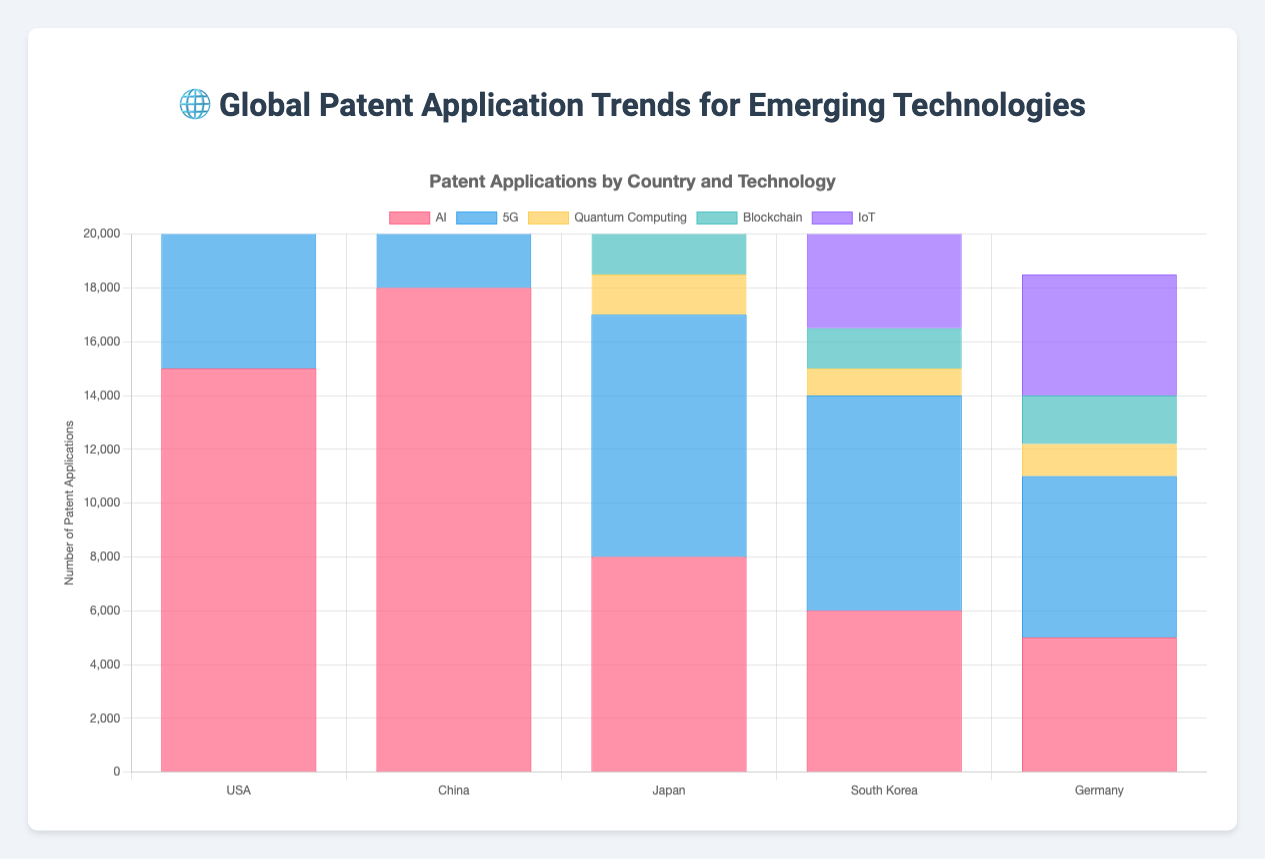Which country has the highest number of patent applications for AI? The bars representing AI patents show China leads with the highest bar.
Answer: China How many more AI patent applications does China have compared to Japan? China's AI patents = 18000; Japan's AI patents = 8000. Difference = 18000 - 8000 = 10000
Answer: 10000 Which technology has the fewest patent applications in Germany? The bar representing Quantum Computing for Germany is the shortest.
Answer: Quantum Computing Comparing AI and 5G patents, which country has the closest number in these categories? USA has 15000 AI and 12000 5G patents, with a difference of 3000, which is relatively small compared to other countries.
Answer: USA What is the total number of patent applications for IoT across all countries? Summing up IoT patents: 10000 (USA) + 12000 (China) + 7000 (Japan) + 5000 (South Korea) + 4500 (Germany) = 38500
Answer: 38500 Which country has the largest gap between AI and Quantum Computing patent applications? USA has 15000 AI and 3000 Quantum Computing patents. The gap = 15000 - 3000 = 12000, which is the largest displayed.
Answer: USA Among South Korea and Germany, which country has more 5G patent applications? South Korea has a higher 5G bar compared to Germany.
Answer: South Korea What's the average number of Blockchain patent applications across the given countries? Summing Blockchain patents: 5000 (USA) + 4000 (China) + 2000 (Japan) + 1500 (South Korea) + 1800 (Germany) = 14300; Average = 14300 / 5 = 2860
Answer: 2860 For which technology does South Korea have the highest number of patents? The bar for 5G patents in South Korea is the highest among its bars.
Answer: 5G How many Quantum Computing patent applications exist in total for Japan and South Korea together? Summing Japan and South Korea's Quantum Computing patents: 1500 (Japan) + 1000 (South Korea) = 2500
Answer: 2500 